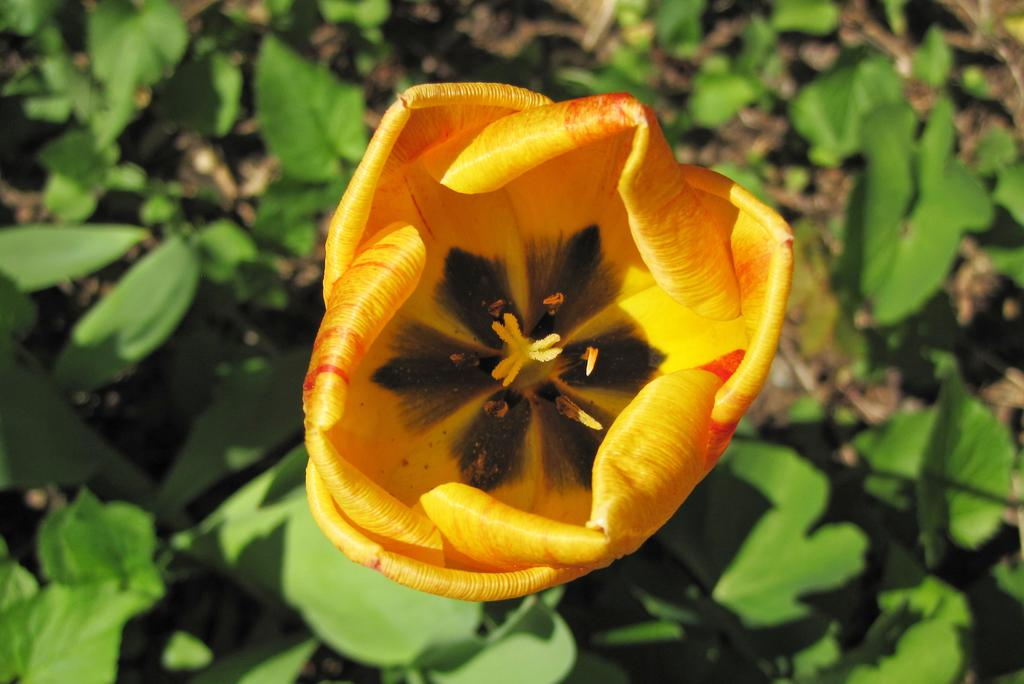What type of plant can be seen in the image? There is a flower in the image. Are there any other parts of the plant visible in the image? Yes, there are leaves in the image. What type of creature is sitting in the crib in the image? There is no creature or crib present in the image; it only features a flower and leaves. What kind of paste is being used to stick the flower to the leaves in the image? There is no paste or indication of the flower being attached to the leaves in the image; they are naturally connected as part of the plant. 